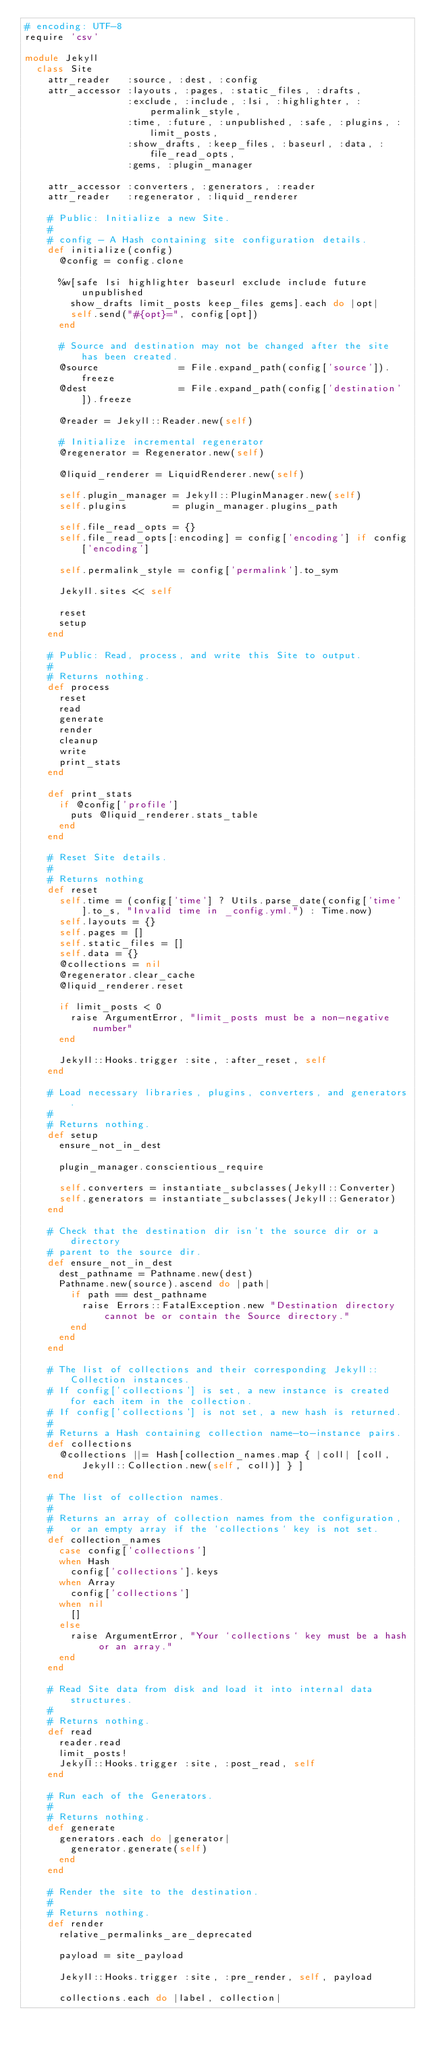<code> <loc_0><loc_0><loc_500><loc_500><_Ruby_># encoding: UTF-8
require 'csv'

module Jekyll
  class Site
    attr_reader   :source, :dest, :config
    attr_accessor :layouts, :pages, :static_files, :drafts,
                  :exclude, :include, :lsi, :highlighter, :permalink_style,
                  :time, :future, :unpublished, :safe, :plugins, :limit_posts,
                  :show_drafts, :keep_files, :baseurl, :data, :file_read_opts,
                  :gems, :plugin_manager

    attr_accessor :converters, :generators, :reader
    attr_reader   :regenerator, :liquid_renderer

    # Public: Initialize a new Site.
    #
    # config - A Hash containing site configuration details.
    def initialize(config)
      @config = config.clone

      %w[safe lsi highlighter baseurl exclude include future unpublished
        show_drafts limit_posts keep_files gems].each do |opt|
        self.send("#{opt}=", config[opt])
      end

      # Source and destination may not be changed after the site has been created.
      @source              = File.expand_path(config['source']).freeze
      @dest                = File.expand_path(config['destination']).freeze

      @reader = Jekyll::Reader.new(self)

      # Initialize incremental regenerator
      @regenerator = Regenerator.new(self)

      @liquid_renderer = LiquidRenderer.new(self)

      self.plugin_manager = Jekyll::PluginManager.new(self)
      self.plugins        = plugin_manager.plugins_path

      self.file_read_opts = {}
      self.file_read_opts[:encoding] = config['encoding'] if config['encoding']

      self.permalink_style = config['permalink'].to_sym

      Jekyll.sites << self

      reset
      setup
    end

    # Public: Read, process, and write this Site to output.
    #
    # Returns nothing.
    def process
      reset
      read
      generate
      render
      cleanup
      write
      print_stats
    end

    def print_stats
      if @config['profile']
        puts @liquid_renderer.stats_table
      end
    end

    # Reset Site details.
    #
    # Returns nothing
    def reset
      self.time = (config['time'] ? Utils.parse_date(config['time'].to_s, "Invalid time in _config.yml.") : Time.now)
      self.layouts = {}
      self.pages = []
      self.static_files = []
      self.data = {}
      @collections = nil
      @regenerator.clear_cache
      @liquid_renderer.reset

      if limit_posts < 0
        raise ArgumentError, "limit_posts must be a non-negative number"
      end

      Jekyll::Hooks.trigger :site, :after_reset, self
    end

    # Load necessary libraries, plugins, converters, and generators.
    #
    # Returns nothing.
    def setup
      ensure_not_in_dest

      plugin_manager.conscientious_require

      self.converters = instantiate_subclasses(Jekyll::Converter)
      self.generators = instantiate_subclasses(Jekyll::Generator)
    end

    # Check that the destination dir isn't the source dir or a directory
    # parent to the source dir.
    def ensure_not_in_dest
      dest_pathname = Pathname.new(dest)
      Pathname.new(source).ascend do |path|
        if path == dest_pathname
          raise Errors::FatalException.new "Destination directory cannot be or contain the Source directory."
        end
      end
    end

    # The list of collections and their corresponding Jekyll::Collection instances.
    # If config['collections'] is set, a new instance is created for each item in the collection.
    # If config['collections'] is not set, a new hash is returned.
    #
    # Returns a Hash containing collection name-to-instance pairs.
    def collections
      @collections ||= Hash[collection_names.map { |coll| [coll, Jekyll::Collection.new(self, coll)] } ]
    end

    # The list of collection names.
    #
    # Returns an array of collection names from the configuration,
    #   or an empty array if the `collections` key is not set.
    def collection_names
      case config['collections']
      when Hash
        config['collections'].keys
      when Array
        config['collections']
      when nil
        []
      else
        raise ArgumentError, "Your `collections` key must be a hash or an array."
      end
    end

    # Read Site data from disk and load it into internal data structures.
    #
    # Returns nothing.
    def read
      reader.read
      limit_posts!
      Jekyll::Hooks.trigger :site, :post_read, self
    end

    # Run each of the Generators.
    #
    # Returns nothing.
    def generate
      generators.each do |generator|
        generator.generate(self)
      end
    end

    # Render the site to the destination.
    #
    # Returns nothing.
    def render
      relative_permalinks_are_deprecated

      payload = site_payload

      Jekyll::Hooks.trigger :site, :pre_render, self, payload

      collections.each do |label, collection|</code> 